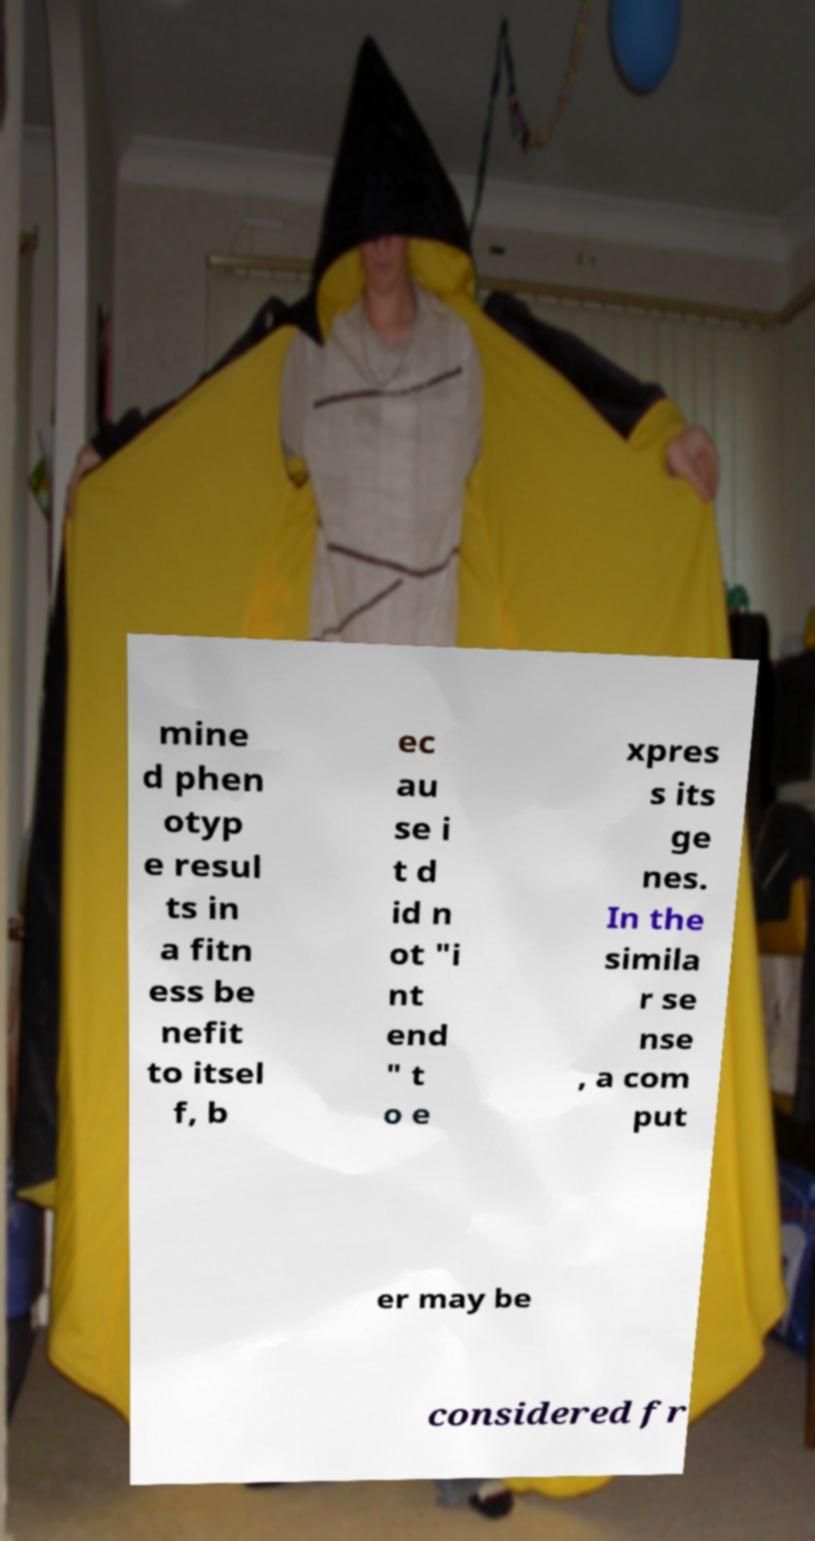Can you read and provide the text displayed in the image?This photo seems to have some interesting text. Can you extract and type it out for me? mine d phen otyp e resul ts in a fitn ess be nefit to itsel f, b ec au se i t d id n ot "i nt end " t o e xpres s its ge nes. In the simila r se nse , a com put er may be considered fr 